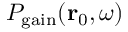Convert formula to latex. <formula><loc_0><loc_0><loc_500><loc_500>P _ { g a i n } ( r _ { 0 } , \omega )</formula> 